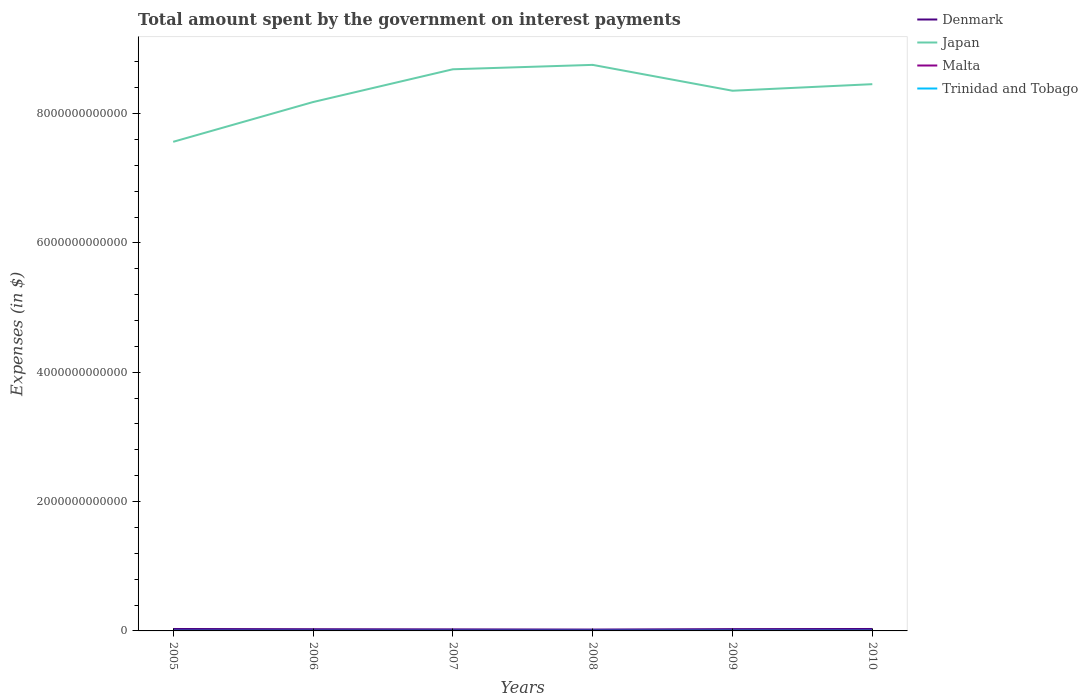Is the number of lines equal to the number of legend labels?
Offer a very short reply. Yes. Across all years, what is the maximum amount spent on interest payments by the government in Malta?
Give a very brief answer. 1.83e+08. In which year was the amount spent on interest payments by the government in Malta maximum?
Offer a terse response. 2009. What is the total amount spent on interest payments by the government in Denmark in the graph?
Your answer should be compact. 6.09e+09. What is the difference between the highest and the second highest amount spent on interest payments by the government in Malta?
Provide a succinct answer. 2.39e+08. Is the amount spent on interest payments by the government in Denmark strictly greater than the amount spent on interest payments by the government in Japan over the years?
Provide a short and direct response. Yes. How many years are there in the graph?
Give a very brief answer. 6. What is the difference between two consecutive major ticks on the Y-axis?
Offer a very short reply. 2.00e+12. Are the values on the major ticks of Y-axis written in scientific E-notation?
Offer a very short reply. No. Does the graph contain any zero values?
Ensure brevity in your answer.  No. Does the graph contain grids?
Provide a succinct answer. No. What is the title of the graph?
Provide a succinct answer. Total amount spent by the government on interest payments. What is the label or title of the Y-axis?
Offer a very short reply. Expenses (in $). What is the Expenses (in $) of Denmark in 2005?
Offer a very short reply. 3.00e+1. What is the Expenses (in $) of Japan in 2005?
Give a very brief answer. 7.56e+12. What is the Expenses (in $) in Malta in 2005?
Your response must be concise. 4.22e+08. What is the Expenses (in $) in Trinidad and Tobago in 2005?
Keep it short and to the point. 2.54e+09. What is the Expenses (in $) in Denmark in 2006?
Your answer should be compact. 2.63e+1. What is the Expenses (in $) of Japan in 2006?
Your response must be concise. 8.18e+12. What is the Expenses (in $) of Malta in 2006?
Ensure brevity in your answer.  4.19e+08. What is the Expenses (in $) in Trinidad and Tobago in 2006?
Offer a very short reply. 2.45e+09. What is the Expenses (in $) of Denmark in 2007?
Offer a very short reply. 2.39e+1. What is the Expenses (in $) in Japan in 2007?
Give a very brief answer. 8.68e+12. What is the Expenses (in $) of Malta in 2007?
Offer a terse response. 4.22e+08. What is the Expenses (in $) in Trinidad and Tobago in 2007?
Your answer should be compact. 2.70e+09. What is the Expenses (in $) in Denmark in 2008?
Provide a short and direct response. 2.09e+1. What is the Expenses (in $) in Japan in 2008?
Make the answer very short. 8.75e+12. What is the Expenses (in $) in Malta in 2008?
Provide a short and direct response. 1.88e+08. What is the Expenses (in $) in Trinidad and Tobago in 2008?
Give a very brief answer. 2.97e+09. What is the Expenses (in $) in Denmark in 2009?
Provide a short and direct response. 2.78e+1. What is the Expenses (in $) in Japan in 2009?
Your response must be concise. 8.35e+12. What is the Expenses (in $) in Malta in 2009?
Provide a succinct answer. 1.83e+08. What is the Expenses (in $) in Trinidad and Tobago in 2009?
Your response must be concise. 3.50e+09. What is the Expenses (in $) in Denmark in 2010?
Keep it short and to the point. 3.00e+1. What is the Expenses (in $) of Japan in 2010?
Your answer should be compact. 8.45e+12. What is the Expenses (in $) in Malta in 2010?
Provide a succinct answer. 1.86e+08. What is the Expenses (in $) in Trinidad and Tobago in 2010?
Your answer should be compact. 3.29e+09. Across all years, what is the maximum Expenses (in $) in Denmark?
Your answer should be very brief. 3.00e+1. Across all years, what is the maximum Expenses (in $) of Japan?
Keep it short and to the point. 8.75e+12. Across all years, what is the maximum Expenses (in $) in Malta?
Provide a succinct answer. 4.22e+08. Across all years, what is the maximum Expenses (in $) in Trinidad and Tobago?
Keep it short and to the point. 3.50e+09. Across all years, what is the minimum Expenses (in $) in Denmark?
Ensure brevity in your answer.  2.09e+1. Across all years, what is the minimum Expenses (in $) in Japan?
Keep it short and to the point. 7.56e+12. Across all years, what is the minimum Expenses (in $) of Malta?
Your answer should be very brief. 1.83e+08. Across all years, what is the minimum Expenses (in $) in Trinidad and Tobago?
Provide a short and direct response. 2.45e+09. What is the total Expenses (in $) in Denmark in the graph?
Your answer should be compact. 1.59e+11. What is the total Expenses (in $) of Japan in the graph?
Make the answer very short. 5.00e+13. What is the total Expenses (in $) in Malta in the graph?
Offer a terse response. 1.82e+09. What is the total Expenses (in $) of Trinidad and Tobago in the graph?
Make the answer very short. 1.75e+1. What is the difference between the Expenses (in $) in Denmark in 2005 and that in 2006?
Offer a terse response. 3.73e+09. What is the difference between the Expenses (in $) of Japan in 2005 and that in 2006?
Your answer should be very brief. -6.15e+11. What is the difference between the Expenses (in $) in Malta in 2005 and that in 2006?
Your response must be concise. 3.44e+06. What is the difference between the Expenses (in $) in Trinidad and Tobago in 2005 and that in 2006?
Provide a succinct answer. 8.82e+07. What is the difference between the Expenses (in $) of Denmark in 2005 and that in 2007?
Your answer should be compact. 6.09e+09. What is the difference between the Expenses (in $) in Japan in 2005 and that in 2007?
Make the answer very short. -1.12e+12. What is the difference between the Expenses (in $) of Malta in 2005 and that in 2007?
Your answer should be compact. -1.02e+05. What is the difference between the Expenses (in $) of Trinidad and Tobago in 2005 and that in 2007?
Your answer should be very brief. -1.57e+08. What is the difference between the Expenses (in $) in Denmark in 2005 and that in 2008?
Offer a terse response. 9.12e+09. What is the difference between the Expenses (in $) in Japan in 2005 and that in 2008?
Keep it short and to the point. -1.19e+12. What is the difference between the Expenses (in $) of Malta in 2005 and that in 2008?
Keep it short and to the point. 2.34e+08. What is the difference between the Expenses (in $) of Trinidad and Tobago in 2005 and that in 2008?
Your response must be concise. -4.26e+08. What is the difference between the Expenses (in $) in Denmark in 2005 and that in 2009?
Offer a very short reply. 2.28e+09. What is the difference between the Expenses (in $) in Japan in 2005 and that in 2009?
Make the answer very short. -7.90e+11. What is the difference between the Expenses (in $) in Malta in 2005 and that in 2009?
Ensure brevity in your answer.  2.39e+08. What is the difference between the Expenses (in $) of Trinidad and Tobago in 2005 and that in 2009?
Provide a short and direct response. -9.58e+08. What is the difference between the Expenses (in $) in Denmark in 2005 and that in 2010?
Your answer should be very brief. 7.00e+07. What is the difference between the Expenses (in $) of Japan in 2005 and that in 2010?
Your answer should be compact. -8.91e+11. What is the difference between the Expenses (in $) of Malta in 2005 and that in 2010?
Provide a short and direct response. 2.36e+08. What is the difference between the Expenses (in $) in Trinidad and Tobago in 2005 and that in 2010?
Keep it short and to the point. -7.49e+08. What is the difference between the Expenses (in $) in Denmark in 2006 and that in 2007?
Make the answer very short. 2.36e+09. What is the difference between the Expenses (in $) in Japan in 2006 and that in 2007?
Ensure brevity in your answer.  -5.07e+11. What is the difference between the Expenses (in $) in Malta in 2006 and that in 2007?
Keep it short and to the point. -3.55e+06. What is the difference between the Expenses (in $) in Trinidad and Tobago in 2006 and that in 2007?
Give a very brief answer. -2.45e+08. What is the difference between the Expenses (in $) of Denmark in 2006 and that in 2008?
Your response must be concise. 5.38e+09. What is the difference between the Expenses (in $) of Japan in 2006 and that in 2008?
Your answer should be compact. -5.75e+11. What is the difference between the Expenses (in $) in Malta in 2006 and that in 2008?
Ensure brevity in your answer.  2.31e+08. What is the difference between the Expenses (in $) of Trinidad and Tobago in 2006 and that in 2008?
Provide a succinct answer. -5.14e+08. What is the difference between the Expenses (in $) of Denmark in 2006 and that in 2009?
Keep it short and to the point. -1.45e+09. What is the difference between the Expenses (in $) of Japan in 2006 and that in 2009?
Ensure brevity in your answer.  -1.75e+11. What is the difference between the Expenses (in $) of Malta in 2006 and that in 2009?
Ensure brevity in your answer.  2.35e+08. What is the difference between the Expenses (in $) of Trinidad and Tobago in 2006 and that in 2009?
Make the answer very short. -1.05e+09. What is the difference between the Expenses (in $) of Denmark in 2006 and that in 2010?
Provide a short and direct response. -3.66e+09. What is the difference between the Expenses (in $) in Japan in 2006 and that in 2010?
Give a very brief answer. -2.76e+11. What is the difference between the Expenses (in $) of Malta in 2006 and that in 2010?
Provide a short and direct response. 2.32e+08. What is the difference between the Expenses (in $) in Trinidad and Tobago in 2006 and that in 2010?
Your answer should be compact. -8.37e+08. What is the difference between the Expenses (in $) of Denmark in 2007 and that in 2008?
Make the answer very short. 3.03e+09. What is the difference between the Expenses (in $) of Japan in 2007 and that in 2008?
Your answer should be compact. -6.80e+1. What is the difference between the Expenses (in $) in Malta in 2007 and that in 2008?
Your answer should be compact. 2.34e+08. What is the difference between the Expenses (in $) of Trinidad and Tobago in 2007 and that in 2008?
Offer a very short reply. -2.69e+08. What is the difference between the Expenses (in $) in Denmark in 2007 and that in 2009?
Offer a terse response. -3.81e+09. What is the difference between the Expenses (in $) in Japan in 2007 and that in 2009?
Your answer should be very brief. 3.32e+11. What is the difference between the Expenses (in $) of Malta in 2007 and that in 2009?
Make the answer very short. 2.39e+08. What is the difference between the Expenses (in $) of Trinidad and Tobago in 2007 and that in 2009?
Keep it short and to the point. -8.02e+08. What is the difference between the Expenses (in $) of Denmark in 2007 and that in 2010?
Your response must be concise. -6.02e+09. What is the difference between the Expenses (in $) of Japan in 2007 and that in 2010?
Offer a very short reply. 2.30e+11. What is the difference between the Expenses (in $) of Malta in 2007 and that in 2010?
Offer a very short reply. 2.36e+08. What is the difference between the Expenses (in $) in Trinidad and Tobago in 2007 and that in 2010?
Your answer should be compact. -5.92e+08. What is the difference between the Expenses (in $) of Denmark in 2008 and that in 2009?
Make the answer very short. -6.84e+09. What is the difference between the Expenses (in $) of Japan in 2008 and that in 2009?
Ensure brevity in your answer.  4.00e+11. What is the difference between the Expenses (in $) of Malta in 2008 and that in 2009?
Your answer should be very brief. 4.39e+06. What is the difference between the Expenses (in $) in Trinidad and Tobago in 2008 and that in 2009?
Give a very brief answer. -5.33e+08. What is the difference between the Expenses (in $) in Denmark in 2008 and that in 2010?
Ensure brevity in your answer.  -9.05e+09. What is the difference between the Expenses (in $) of Japan in 2008 and that in 2010?
Your answer should be very brief. 2.98e+11. What is the difference between the Expenses (in $) of Malta in 2008 and that in 2010?
Provide a succinct answer. 1.37e+06. What is the difference between the Expenses (in $) of Trinidad and Tobago in 2008 and that in 2010?
Offer a very short reply. -3.23e+08. What is the difference between the Expenses (in $) in Denmark in 2009 and that in 2010?
Provide a succinct answer. -2.21e+09. What is the difference between the Expenses (in $) in Japan in 2009 and that in 2010?
Offer a very short reply. -1.02e+11. What is the difference between the Expenses (in $) in Malta in 2009 and that in 2010?
Offer a very short reply. -3.02e+06. What is the difference between the Expenses (in $) in Trinidad and Tobago in 2009 and that in 2010?
Make the answer very short. 2.10e+08. What is the difference between the Expenses (in $) in Denmark in 2005 and the Expenses (in $) in Japan in 2006?
Make the answer very short. -8.15e+12. What is the difference between the Expenses (in $) of Denmark in 2005 and the Expenses (in $) of Malta in 2006?
Make the answer very short. 2.96e+1. What is the difference between the Expenses (in $) of Denmark in 2005 and the Expenses (in $) of Trinidad and Tobago in 2006?
Your answer should be compact. 2.76e+1. What is the difference between the Expenses (in $) in Japan in 2005 and the Expenses (in $) in Malta in 2006?
Your answer should be compact. 7.56e+12. What is the difference between the Expenses (in $) of Japan in 2005 and the Expenses (in $) of Trinidad and Tobago in 2006?
Make the answer very short. 7.56e+12. What is the difference between the Expenses (in $) in Malta in 2005 and the Expenses (in $) in Trinidad and Tobago in 2006?
Offer a very short reply. -2.03e+09. What is the difference between the Expenses (in $) of Denmark in 2005 and the Expenses (in $) of Japan in 2007?
Your answer should be very brief. -8.65e+12. What is the difference between the Expenses (in $) of Denmark in 2005 and the Expenses (in $) of Malta in 2007?
Your answer should be compact. 2.96e+1. What is the difference between the Expenses (in $) in Denmark in 2005 and the Expenses (in $) in Trinidad and Tobago in 2007?
Provide a short and direct response. 2.73e+1. What is the difference between the Expenses (in $) in Japan in 2005 and the Expenses (in $) in Malta in 2007?
Your response must be concise. 7.56e+12. What is the difference between the Expenses (in $) of Japan in 2005 and the Expenses (in $) of Trinidad and Tobago in 2007?
Keep it short and to the point. 7.56e+12. What is the difference between the Expenses (in $) in Malta in 2005 and the Expenses (in $) in Trinidad and Tobago in 2007?
Keep it short and to the point. -2.28e+09. What is the difference between the Expenses (in $) of Denmark in 2005 and the Expenses (in $) of Japan in 2008?
Keep it short and to the point. -8.72e+12. What is the difference between the Expenses (in $) in Denmark in 2005 and the Expenses (in $) in Malta in 2008?
Offer a terse response. 2.98e+1. What is the difference between the Expenses (in $) of Denmark in 2005 and the Expenses (in $) of Trinidad and Tobago in 2008?
Make the answer very short. 2.71e+1. What is the difference between the Expenses (in $) in Japan in 2005 and the Expenses (in $) in Malta in 2008?
Keep it short and to the point. 7.56e+12. What is the difference between the Expenses (in $) of Japan in 2005 and the Expenses (in $) of Trinidad and Tobago in 2008?
Keep it short and to the point. 7.56e+12. What is the difference between the Expenses (in $) of Malta in 2005 and the Expenses (in $) of Trinidad and Tobago in 2008?
Provide a succinct answer. -2.55e+09. What is the difference between the Expenses (in $) of Denmark in 2005 and the Expenses (in $) of Japan in 2009?
Your response must be concise. -8.32e+12. What is the difference between the Expenses (in $) of Denmark in 2005 and the Expenses (in $) of Malta in 2009?
Your answer should be compact. 2.99e+1. What is the difference between the Expenses (in $) of Denmark in 2005 and the Expenses (in $) of Trinidad and Tobago in 2009?
Your answer should be compact. 2.65e+1. What is the difference between the Expenses (in $) of Japan in 2005 and the Expenses (in $) of Malta in 2009?
Offer a terse response. 7.56e+12. What is the difference between the Expenses (in $) of Japan in 2005 and the Expenses (in $) of Trinidad and Tobago in 2009?
Your answer should be compact. 7.56e+12. What is the difference between the Expenses (in $) of Malta in 2005 and the Expenses (in $) of Trinidad and Tobago in 2009?
Offer a very short reply. -3.08e+09. What is the difference between the Expenses (in $) of Denmark in 2005 and the Expenses (in $) of Japan in 2010?
Offer a very short reply. -8.42e+12. What is the difference between the Expenses (in $) in Denmark in 2005 and the Expenses (in $) in Malta in 2010?
Provide a short and direct response. 2.98e+1. What is the difference between the Expenses (in $) of Denmark in 2005 and the Expenses (in $) of Trinidad and Tobago in 2010?
Provide a succinct answer. 2.67e+1. What is the difference between the Expenses (in $) of Japan in 2005 and the Expenses (in $) of Malta in 2010?
Your answer should be very brief. 7.56e+12. What is the difference between the Expenses (in $) in Japan in 2005 and the Expenses (in $) in Trinidad and Tobago in 2010?
Your response must be concise. 7.56e+12. What is the difference between the Expenses (in $) in Malta in 2005 and the Expenses (in $) in Trinidad and Tobago in 2010?
Your answer should be compact. -2.87e+09. What is the difference between the Expenses (in $) in Denmark in 2006 and the Expenses (in $) in Japan in 2007?
Offer a very short reply. -8.66e+12. What is the difference between the Expenses (in $) in Denmark in 2006 and the Expenses (in $) in Malta in 2007?
Provide a succinct answer. 2.59e+1. What is the difference between the Expenses (in $) of Denmark in 2006 and the Expenses (in $) of Trinidad and Tobago in 2007?
Ensure brevity in your answer.  2.36e+1. What is the difference between the Expenses (in $) in Japan in 2006 and the Expenses (in $) in Malta in 2007?
Offer a very short reply. 8.18e+12. What is the difference between the Expenses (in $) in Japan in 2006 and the Expenses (in $) in Trinidad and Tobago in 2007?
Make the answer very short. 8.17e+12. What is the difference between the Expenses (in $) of Malta in 2006 and the Expenses (in $) of Trinidad and Tobago in 2007?
Offer a very short reply. -2.28e+09. What is the difference between the Expenses (in $) of Denmark in 2006 and the Expenses (in $) of Japan in 2008?
Your answer should be compact. -8.73e+12. What is the difference between the Expenses (in $) in Denmark in 2006 and the Expenses (in $) in Malta in 2008?
Give a very brief answer. 2.61e+1. What is the difference between the Expenses (in $) in Denmark in 2006 and the Expenses (in $) in Trinidad and Tobago in 2008?
Ensure brevity in your answer.  2.33e+1. What is the difference between the Expenses (in $) of Japan in 2006 and the Expenses (in $) of Malta in 2008?
Your answer should be very brief. 8.18e+12. What is the difference between the Expenses (in $) of Japan in 2006 and the Expenses (in $) of Trinidad and Tobago in 2008?
Keep it short and to the point. 8.17e+12. What is the difference between the Expenses (in $) in Malta in 2006 and the Expenses (in $) in Trinidad and Tobago in 2008?
Keep it short and to the point. -2.55e+09. What is the difference between the Expenses (in $) in Denmark in 2006 and the Expenses (in $) in Japan in 2009?
Offer a terse response. -8.33e+12. What is the difference between the Expenses (in $) of Denmark in 2006 and the Expenses (in $) of Malta in 2009?
Keep it short and to the point. 2.61e+1. What is the difference between the Expenses (in $) of Denmark in 2006 and the Expenses (in $) of Trinidad and Tobago in 2009?
Offer a very short reply. 2.28e+1. What is the difference between the Expenses (in $) in Japan in 2006 and the Expenses (in $) in Malta in 2009?
Your answer should be very brief. 8.18e+12. What is the difference between the Expenses (in $) of Japan in 2006 and the Expenses (in $) of Trinidad and Tobago in 2009?
Your response must be concise. 8.17e+12. What is the difference between the Expenses (in $) in Malta in 2006 and the Expenses (in $) in Trinidad and Tobago in 2009?
Your response must be concise. -3.08e+09. What is the difference between the Expenses (in $) of Denmark in 2006 and the Expenses (in $) of Japan in 2010?
Give a very brief answer. -8.43e+12. What is the difference between the Expenses (in $) of Denmark in 2006 and the Expenses (in $) of Malta in 2010?
Your answer should be compact. 2.61e+1. What is the difference between the Expenses (in $) in Denmark in 2006 and the Expenses (in $) in Trinidad and Tobago in 2010?
Your response must be concise. 2.30e+1. What is the difference between the Expenses (in $) in Japan in 2006 and the Expenses (in $) in Malta in 2010?
Make the answer very short. 8.18e+12. What is the difference between the Expenses (in $) in Japan in 2006 and the Expenses (in $) in Trinidad and Tobago in 2010?
Provide a succinct answer. 8.17e+12. What is the difference between the Expenses (in $) of Malta in 2006 and the Expenses (in $) of Trinidad and Tobago in 2010?
Offer a terse response. -2.87e+09. What is the difference between the Expenses (in $) in Denmark in 2007 and the Expenses (in $) in Japan in 2008?
Your response must be concise. -8.73e+12. What is the difference between the Expenses (in $) in Denmark in 2007 and the Expenses (in $) in Malta in 2008?
Offer a terse response. 2.38e+1. What is the difference between the Expenses (in $) of Denmark in 2007 and the Expenses (in $) of Trinidad and Tobago in 2008?
Your answer should be compact. 2.10e+1. What is the difference between the Expenses (in $) of Japan in 2007 and the Expenses (in $) of Malta in 2008?
Your answer should be compact. 8.68e+12. What is the difference between the Expenses (in $) of Japan in 2007 and the Expenses (in $) of Trinidad and Tobago in 2008?
Your answer should be compact. 8.68e+12. What is the difference between the Expenses (in $) of Malta in 2007 and the Expenses (in $) of Trinidad and Tobago in 2008?
Your answer should be compact. -2.55e+09. What is the difference between the Expenses (in $) in Denmark in 2007 and the Expenses (in $) in Japan in 2009?
Make the answer very short. -8.33e+12. What is the difference between the Expenses (in $) in Denmark in 2007 and the Expenses (in $) in Malta in 2009?
Your answer should be very brief. 2.38e+1. What is the difference between the Expenses (in $) of Denmark in 2007 and the Expenses (in $) of Trinidad and Tobago in 2009?
Offer a very short reply. 2.04e+1. What is the difference between the Expenses (in $) in Japan in 2007 and the Expenses (in $) in Malta in 2009?
Keep it short and to the point. 8.68e+12. What is the difference between the Expenses (in $) in Japan in 2007 and the Expenses (in $) in Trinidad and Tobago in 2009?
Offer a terse response. 8.68e+12. What is the difference between the Expenses (in $) of Malta in 2007 and the Expenses (in $) of Trinidad and Tobago in 2009?
Ensure brevity in your answer.  -3.08e+09. What is the difference between the Expenses (in $) of Denmark in 2007 and the Expenses (in $) of Japan in 2010?
Make the answer very short. -8.43e+12. What is the difference between the Expenses (in $) in Denmark in 2007 and the Expenses (in $) in Malta in 2010?
Make the answer very short. 2.38e+1. What is the difference between the Expenses (in $) of Denmark in 2007 and the Expenses (in $) of Trinidad and Tobago in 2010?
Keep it short and to the point. 2.07e+1. What is the difference between the Expenses (in $) of Japan in 2007 and the Expenses (in $) of Malta in 2010?
Your answer should be compact. 8.68e+12. What is the difference between the Expenses (in $) of Japan in 2007 and the Expenses (in $) of Trinidad and Tobago in 2010?
Offer a very short reply. 8.68e+12. What is the difference between the Expenses (in $) in Malta in 2007 and the Expenses (in $) in Trinidad and Tobago in 2010?
Make the answer very short. -2.87e+09. What is the difference between the Expenses (in $) of Denmark in 2008 and the Expenses (in $) of Japan in 2009?
Your answer should be very brief. -8.33e+12. What is the difference between the Expenses (in $) in Denmark in 2008 and the Expenses (in $) in Malta in 2009?
Give a very brief answer. 2.07e+1. What is the difference between the Expenses (in $) of Denmark in 2008 and the Expenses (in $) of Trinidad and Tobago in 2009?
Offer a terse response. 1.74e+1. What is the difference between the Expenses (in $) in Japan in 2008 and the Expenses (in $) in Malta in 2009?
Offer a very short reply. 8.75e+12. What is the difference between the Expenses (in $) in Japan in 2008 and the Expenses (in $) in Trinidad and Tobago in 2009?
Provide a succinct answer. 8.75e+12. What is the difference between the Expenses (in $) of Malta in 2008 and the Expenses (in $) of Trinidad and Tobago in 2009?
Provide a short and direct response. -3.31e+09. What is the difference between the Expenses (in $) in Denmark in 2008 and the Expenses (in $) in Japan in 2010?
Provide a succinct answer. -8.43e+12. What is the difference between the Expenses (in $) in Denmark in 2008 and the Expenses (in $) in Malta in 2010?
Offer a very short reply. 2.07e+1. What is the difference between the Expenses (in $) in Denmark in 2008 and the Expenses (in $) in Trinidad and Tobago in 2010?
Offer a very short reply. 1.76e+1. What is the difference between the Expenses (in $) in Japan in 2008 and the Expenses (in $) in Malta in 2010?
Give a very brief answer. 8.75e+12. What is the difference between the Expenses (in $) of Japan in 2008 and the Expenses (in $) of Trinidad and Tobago in 2010?
Keep it short and to the point. 8.75e+12. What is the difference between the Expenses (in $) in Malta in 2008 and the Expenses (in $) in Trinidad and Tobago in 2010?
Make the answer very short. -3.10e+09. What is the difference between the Expenses (in $) in Denmark in 2009 and the Expenses (in $) in Japan in 2010?
Keep it short and to the point. -8.43e+12. What is the difference between the Expenses (in $) in Denmark in 2009 and the Expenses (in $) in Malta in 2010?
Your response must be concise. 2.76e+1. What is the difference between the Expenses (in $) in Denmark in 2009 and the Expenses (in $) in Trinidad and Tobago in 2010?
Provide a succinct answer. 2.45e+1. What is the difference between the Expenses (in $) in Japan in 2009 and the Expenses (in $) in Malta in 2010?
Offer a very short reply. 8.35e+12. What is the difference between the Expenses (in $) in Japan in 2009 and the Expenses (in $) in Trinidad and Tobago in 2010?
Give a very brief answer. 8.35e+12. What is the difference between the Expenses (in $) in Malta in 2009 and the Expenses (in $) in Trinidad and Tobago in 2010?
Provide a succinct answer. -3.11e+09. What is the average Expenses (in $) of Denmark per year?
Provide a succinct answer. 2.65e+1. What is the average Expenses (in $) in Japan per year?
Ensure brevity in your answer.  8.33e+12. What is the average Expenses (in $) of Malta per year?
Your answer should be compact. 3.03e+08. What is the average Expenses (in $) of Trinidad and Tobago per year?
Your answer should be very brief. 2.91e+09. In the year 2005, what is the difference between the Expenses (in $) of Denmark and Expenses (in $) of Japan?
Keep it short and to the point. -7.53e+12. In the year 2005, what is the difference between the Expenses (in $) in Denmark and Expenses (in $) in Malta?
Offer a terse response. 2.96e+1. In the year 2005, what is the difference between the Expenses (in $) of Denmark and Expenses (in $) of Trinidad and Tobago?
Provide a short and direct response. 2.75e+1. In the year 2005, what is the difference between the Expenses (in $) in Japan and Expenses (in $) in Malta?
Your answer should be compact. 7.56e+12. In the year 2005, what is the difference between the Expenses (in $) of Japan and Expenses (in $) of Trinidad and Tobago?
Offer a very short reply. 7.56e+12. In the year 2005, what is the difference between the Expenses (in $) of Malta and Expenses (in $) of Trinidad and Tobago?
Keep it short and to the point. -2.12e+09. In the year 2006, what is the difference between the Expenses (in $) of Denmark and Expenses (in $) of Japan?
Your answer should be compact. -8.15e+12. In the year 2006, what is the difference between the Expenses (in $) of Denmark and Expenses (in $) of Malta?
Keep it short and to the point. 2.59e+1. In the year 2006, what is the difference between the Expenses (in $) in Denmark and Expenses (in $) in Trinidad and Tobago?
Ensure brevity in your answer.  2.38e+1. In the year 2006, what is the difference between the Expenses (in $) in Japan and Expenses (in $) in Malta?
Give a very brief answer. 8.18e+12. In the year 2006, what is the difference between the Expenses (in $) in Japan and Expenses (in $) in Trinidad and Tobago?
Offer a very short reply. 8.18e+12. In the year 2006, what is the difference between the Expenses (in $) of Malta and Expenses (in $) of Trinidad and Tobago?
Provide a short and direct response. -2.03e+09. In the year 2007, what is the difference between the Expenses (in $) in Denmark and Expenses (in $) in Japan?
Make the answer very short. -8.66e+12. In the year 2007, what is the difference between the Expenses (in $) of Denmark and Expenses (in $) of Malta?
Give a very brief answer. 2.35e+1. In the year 2007, what is the difference between the Expenses (in $) of Denmark and Expenses (in $) of Trinidad and Tobago?
Make the answer very short. 2.12e+1. In the year 2007, what is the difference between the Expenses (in $) of Japan and Expenses (in $) of Malta?
Your answer should be compact. 8.68e+12. In the year 2007, what is the difference between the Expenses (in $) of Japan and Expenses (in $) of Trinidad and Tobago?
Offer a very short reply. 8.68e+12. In the year 2007, what is the difference between the Expenses (in $) of Malta and Expenses (in $) of Trinidad and Tobago?
Your answer should be compact. -2.28e+09. In the year 2008, what is the difference between the Expenses (in $) of Denmark and Expenses (in $) of Japan?
Ensure brevity in your answer.  -8.73e+12. In the year 2008, what is the difference between the Expenses (in $) in Denmark and Expenses (in $) in Malta?
Offer a very short reply. 2.07e+1. In the year 2008, what is the difference between the Expenses (in $) of Denmark and Expenses (in $) of Trinidad and Tobago?
Provide a short and direct response. 1.79e+1. In the year 2008, what is the difference between the Expenses (in $) in Japan and Expenses (in $) in Malta?
Provide a succinct answer. 8.75e+12. In the year 2008, what is the difference between the Expenses (in $) of Japan and Expenses (in $) of Trinidad and Tobago?
Offer a very short reply. 8.75e+12. In the year 2008, what is the difference between the Expenses (in $) of Malta and Expenses (in $) of Trinidad and Tobago?
Give a very brief answer. -2.78e+09. In the year 2009, what is the difference between the Expenses (in $) of Denmark and Expenses (in $) of Japan?
Give a very brief answer. -8.32e+12. In the year 2009, what is the difference between the Expenses (in $) in Denmark and Expenses (in $) in Malta?
Keep it short and to the point. 2.76e+1. In the year 2009, what is the difference between the Expenses (in $) in Denmark and Expenses (in $) in Trinidad and Tobago?
Make the answer very short. 2.43e+1. In the year 2009, what is the difference between the Expenses (in $) in Japan and Expenses (in $) in Malta?
Keep it short and to the point. 8.35e+12. In the year 2009, what is the difference between the Expenses (in $) of Japan and Expenses (in $) of Trinidad and Tobago?
Offer a terse response. 8.35e+12. In the year 2009, what is the difference between the Expenses (in $) of Malta and Expenses (in $) of Trinidad and Tobago?
Give a very brief answer. -3.32e+09. In the year 2010, what is the difference between the Expenses (in $) of Denmark and Expenses (in $) of Japan?
Offer a very short reply. -8.42e+12. In the year 2010, what is the difference between the Expenses (in $) of Denmark and Expenses (in $) of Malta?
Your response must be concise. 2.98e+1. In the year 2010, what is the difference between the Expenses (in $) in Denmark and Expenses (in $) in Trinidad and Tobago?
Make the answer very short. 2.67e+1. In the year 2010, what is the difference between the Expenses (in $) in Japan and Expenses (in $) in Malta?
Your answer should be very brief. 8.45e+12. In the year 2010, what is the difference between the Expenses (in $) in Japan and Expenses (in $) in Trinidad and Tobago?
Offer a terse response. 8.45e+12. In the year 2010, what is the difference between the Expenses (in $) in Malta and Expenses (in $) in Trinidad and Tobago?
Offer a terse response. -3.10e+09. What is the ratio of the Expenses (in $) of Denmark in 2005 to that in 2006?
Your response must be concise. 1.14. What is the ratio of the Expenses (in $) in Japan in 2005 to that in 2006?
Your answer should be very brief. 0.92. What is the ratio of the Expenses (in $) of Malta in 2005 to that in 2006?
Provide a short and direct response. 1.01. What is the ratio of the Expenses (in $) of Trinidad and Tobago in 2005 to that in 2006?
Your response must be concise. 1.04. What is the ratio of the Expenses (in $) of Denmark in 2005 to that in 2007?
Make the answer very short. 1.25. What is the ratio of the Expenses (in $) of Japan in 2005 to that in 2007?
Offer a terse response. 0.87. What is the ratio of the Expenses (in $) in Malta in 2005 to that in 2007?
Your response must be concise. 1. What is the ratio of the Expenses (in $) of Trinidad and Tobago in 2005 to that in 2007?
Offer a terse response. 0.94. What is the ratio of the Expenses (in $) of Denmark in 2005 to that in 2008?
Provide a succinct answer. 1.44. What is the ratio of the Expenses (in $) of Japan in 2005 to that in 2008?
Your answer should be very brief. 0.86. What is the ratio of the Expenses (in $) of Malta in 2005 to that in 2008?
Offer a very short reply. 2.25. What is the ratio of the Expenses (in $) of Trinidad and Tobago in 2005 to that in 2008?
Give a very brief answer. 0.86. What is the ratio of the Expenses (in $) in Denmark in 2005 to that in 2009?
Provide a short and direct response. 1.08. What is the ratio of the Expenses (in $) in Japan in 2005 to that in 2009?
Offer a terse response. 0.91. What is the ratio of the Expenses (in $) in Malta in 2005 to that in 2009?
Provide a short and direct response. 2.3. What is the ratio of the Expenses (in $) in Trinidad and Tobago in 2005 to that in 2009?
Your response must be concise. 0.73. What is the ratio of the Expenses (in $) of Japan in 2005 to that in 2010?
Provide a short and direct response. 0.89. What is the ratio of the Expenses (in $) of Malta in 2005 to that in 2010?
Give a very brief answer. 2.27. What is the ratio of the Expenses (in $) of Trinidad and Tobago in 2005 to that in 2010?
Give a very brief answer. 0.77. What is the ratio of the Expenses (in $) in Denmark in 2006 to that in 2007?
Provide a succinct answer. 1.1. What is the ratio of the Expenses (in $) in Japan in 2006 to that in 2007?
Keep it short and to the point. 0.94. What is the ratio of the Expenses (in $) of Trinidad and Tobago in 2006 to that in 2007?
Provide a succinct answer. 0.91. What is the ratio of the Expenses (in $) in Denmark in 2006 to that in 2008?
Give a very brief answer. 1.26. What is the ratio of the Expenses (in $) of Japan in 2006 to that in 2008?
Keep it short and to the point. 0.93. What is the ratio of the Expenses (in $) of Malta in 2006 to that in 2008?
Ensure brevity in your answer.  2.23. What is the ratio of the Expenses (in $) in Trinidad and Tobago in 2006 to that in 2008?
Your response must be concise. 0.83. What is the ratio of the Expenses (in $) of Denmark in 2006 to that in 2009?
Provide a short and direct response. 0.95. What is the ratio of the Expenses (in $) of Japan in 2006 to that in 2009?
Your answer should be very brief. 0.98. What is the ratio of the Expenses (in $) in Malta in 2006 to that in 2009?
Your answer should be compact. 2.28. What is the ratio of the Expenses (in $) of Trinidad and Tobago in 2006 to that in 2009?
Offer a very short reply. 0.7. What is the ratio of the Expenses (in $) in Denmark in 2006 to that in 2010?
Your answer should be very brief. 0.88. What is the ratio of the Expenses (in $) of Japan in 2006 to that in 2010?
Offer a terse response. 0.97. What is the ratio of the Expenses (in $) in Malta in 2006 to that in 2010?
Keep it short and to the point. 2.25. What is the ratio of the Expenses (in $) of Trinidad and Tobago in 2006 to that in 2010?
Make the answer very short. 0.75. What is the ratio of the Expenses (in $) of Denmark in 2007 to that in 2008?
Your answer should be very brief. 1.14. What is the ratio of the Expenses (in $) in Malta in 2007 to that in 2008?
Keep it short and to the point. 2.25. What is the ratio of the Expenses (in $) in Trinidad and Tobago in 2007 to that in 2008?
Give a very brief answer. 0.91. What is the ratio of the Expenses (in $) in Denmark in 2007 to that in 2009?
Offer a terse response. 0.86. What is the ratio of the Expenses (in $) of Japan in 2007 to that in 2009?
Keep it short and to the point. 1.04. What is the ratio of the Expenses (in $) of Malta in 2007 to that in 2009?
Ensure brevity in your answer.  2.3. What is the ratio of the Expenses (in $) of Trinidad and Tobago in 2007 to that in 2009?
Your answer should be very brief. 0.77. What is the ratio of the Expenses (in $) of Denmark in 2007 to that in 2010?
Offer a terse response. 0.8. What is the ratio of the Expenses (in $) in Japan in 2007 to that in 2010?
Your answer should be compact. 1.03. What is the ratio of the Expenses (in $) in Malta in 2007 to that in 2010?
Provide a short and direct response. 2.27. What is the ratio of the Expenses (in $) in Trinidad and Tobago in 2007 to that in 2010?
Your response must be concise. 0.82. What is the ratio of the Expenses (in $) of Denmark in 2008 to that in 2009?
Provide a succinct answer. 0.75. What is the ratio of the Expenses (in $) of Japan in 2008 to that in 2009?
Give a very brief answer. 1.05. What is the ratio of the Expenses (in $) of Malta in 2008 to that in 2009?
Ensure brevity in your answer.  1.02. What is the ratio of the Expenses (in $) in Trinidad and Tobago in 2008 to that in 2009?
Offer a terse response. 0.85. What is the ratio of the Expenses (in $) of Denmark in 2008 to that in 2010?
Ensure brevity in your answer.  0.7. What is the ratio of the Expenses (in $) of Japan in 2008 to that in 2010?
Ensure brevity in your answer.  1.04. What is the ratio of the Expenses (in $) of Malta in 2008 to that in 2010?
Make the answer very short. 1.01. What is the ratio of the Expenses (in $) in Trinidad and Tobago in 2008 to that in 2010?
Ensure brevity in your answer.  0.9. What is the ratio of the Expenses (in $) in Denmark in 2009 to that in 2010?
Your response must be concise. 0.93. What is the ratio of the Expenses (in $) in Malta in 2009 to that in 2010?
Make the answer very short. 0.98. What is the ratio of the Expenses (in $) in Trinidad and Tobago in 2009 to that in 2010?
Your response must be concise. 1.06. What is the difference between the highest and the second highest Expenses (in $) of Denmark?
Your response must be concise. 7.00e+07. What is the difference between the highest and the second highest Expenses (in $) of Japan?
Provide a short and direct response. 6.80e+1. What is the difference between the highest and the second highest Expenses (in $) in Malta?
Your answer should be compact. 1.02e+05. What is the difference between the highest and the second highest Expenses (in $) of Trinidad and Tobago?
Offer a terse response. 2.10e+08. What is the difference between the highest and the lowest Expenses (in $) of Denmark?
Offer a terse response. 9.12e+09. What is the difference between the highest and the lowest Expenses (in $) of Japan?
Offer a very short reply. 1.19e+12. What is the difference between the highest and the lowest Expenses (in $) in Malta?
Offer a terse response. 2.39e+08. What is the difference between the highest and the lowest Expenses (in $) in Trinidad and Tobago?
Provide a succinct answer. 1.05e+09. 